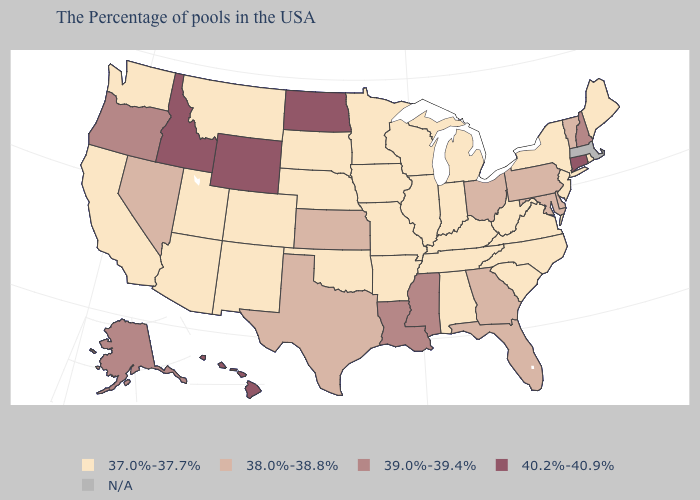Does the first symbol in the legend represent the smallest category?
Short answer required. Yes. Name the states that have a value in the range 40.2%-40.9%?
Give a very brief answer. Connecticut, North Dakota, Wyoming, Idaho, Hawaii. Among the states that border Nevada , which have the highest value?
Write a very short answer. Idaho. What is the highest value in the USA?
Give a very brief answer. 40.2%-40.9%. Name the states that have a value in the range 38.0%-38.8%?
Keep it brief. Vermont, Delaware, Maryland, Pennsylvania, Ohio, Florida, Georgia, Kansas, Texas, Nevada. What is the value of Delaware?
Quick response, please. 38.0%-38.8%. Name the states that have a value in the range 38.0%-38.8%?
Keep it brief. Vermont, Delaware, Maryland, Pennsylvania, Ohio, Florida, Georgia, Kansas, Texas, Nevada. Does the map have missing data?
Short answer required. Yes. What is the highest value in the USA?
Write a very short answer. 40.2%-40.9%. Name the states that have a value in the range 37.0%-37.7%?
Short answer required. Maine, Rhode Island, New York, New Jersey, Virginia, North Carolina, South Carolina, West Virginia, Michigan, Kentucky, Indiana, Alabama, Tennessee, Wisconsin, Illinois, Missouri, Arkansas, Minnesota, Iowa, Nebraska, Oklahoma, South Dakota, Colorado, New Mexico, Utah, Montana, Arizona, California, Washington. Does Montana have the lowest value in the West?
Quick response, please. Yes. Does the map have missing data?
Give a very brief answer. Yes. What is the lowest value in the MidWest?
Write a very short answer. 37.0%-37.7%. Among the states that border North Dakota , which have the lowest value?
Give a very brief answer. Minnesota, South Dakota, Montana. 